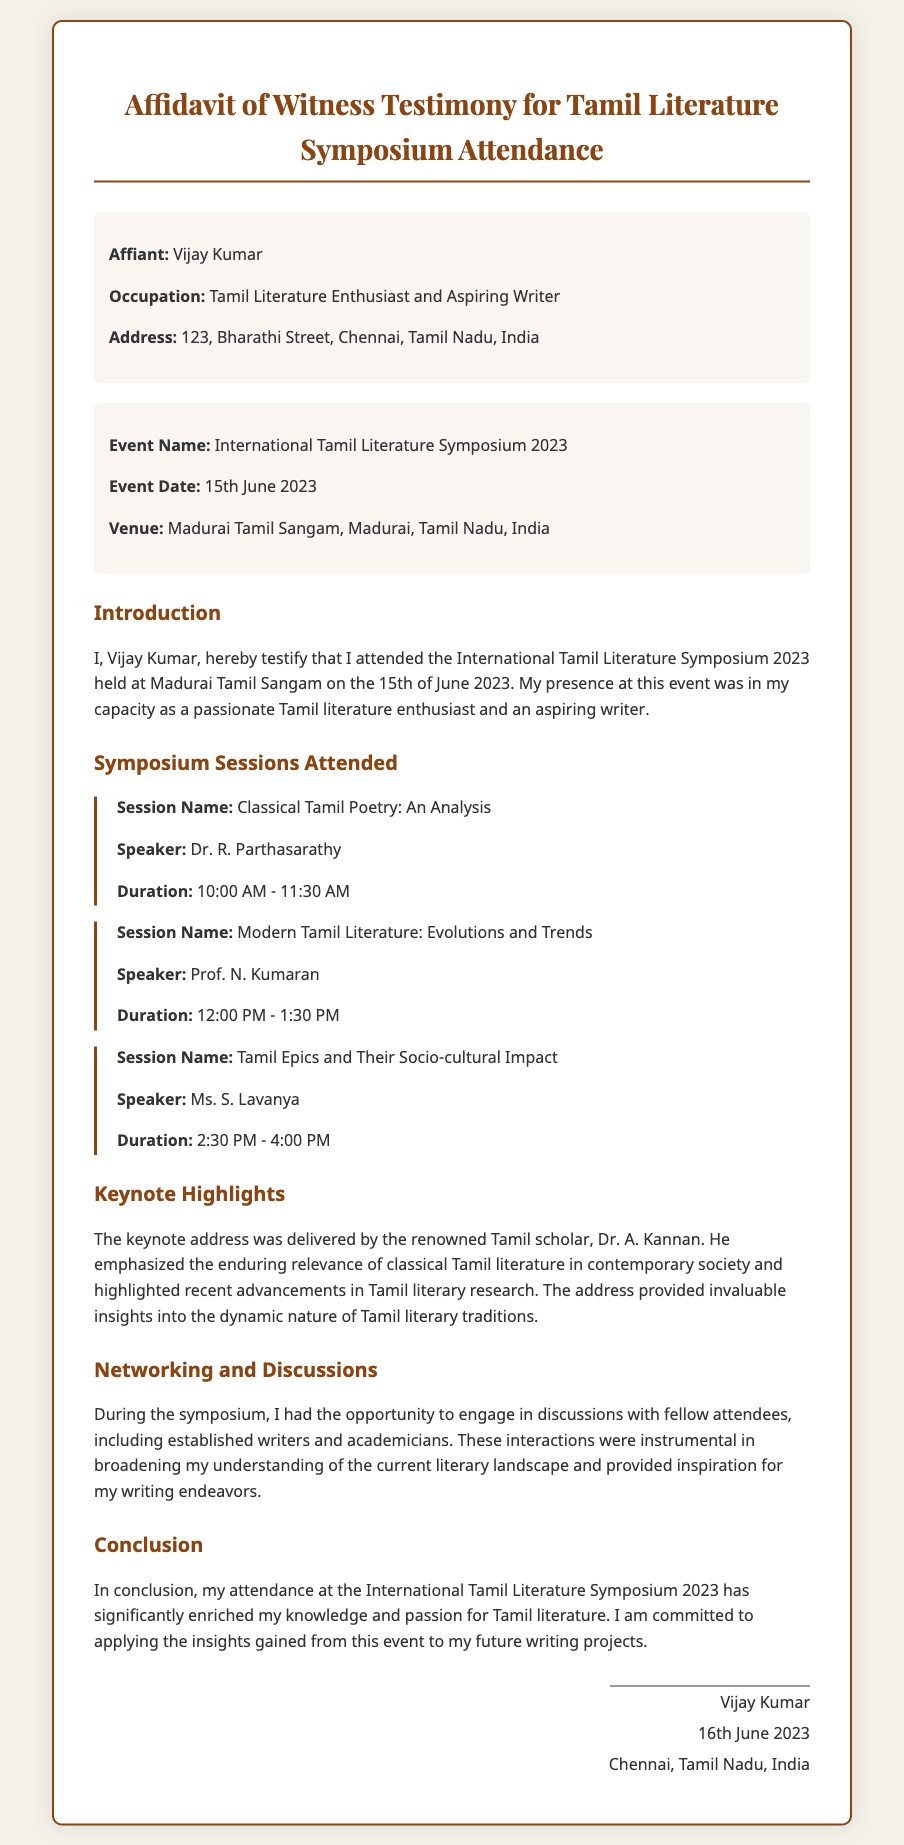What is the name of the affiant? The affiant is the person affirming the statement in the document, which is mentioned as Vijay Kumar.
Answer: Vijay Kumar What is the date of the symposium? The document specifies the date of the event as the 15th of June 2023.
Answer: 15th June 2023 Where was the symposium held? The venue of the symposium is noted in the document as Madurai Tamil Sangam, Madurai, Tamil Nadu, India.
Answer: Madurai Tamil Sangam, Madurai, Tamil Nadu, India Who delivered the keynote address? The document highlights that the keynote address was delivered by Dr. A. Kannan.
Answer: Dr. A. Kannan What is the total number of sessions attended? The document lists three sessions attended during the symposium.
Answer: Three What is one of the topics discussed in a session? The sessions cover various topics, one of which is "Classical Tamil Poetry: An Analysis."
Answer: Classical Tamil Poetry: An Analysis What is the occupation of the affiant? The document states the occupation of the affiant as "Tamil Literature Enthusiast and Aspiring Writer."
Answer: Tamil Literature Enthusiast and Aspiring Writer What theme does the keynote emphasize? The keynote address emphasizes the relevance of classical Tamil literature in contemporary society.
Answer: Relevance of classical Tamil literature What kind of document is this? This is an affidavit, which is a formal statement made under oath.
Answer: Affidavit 